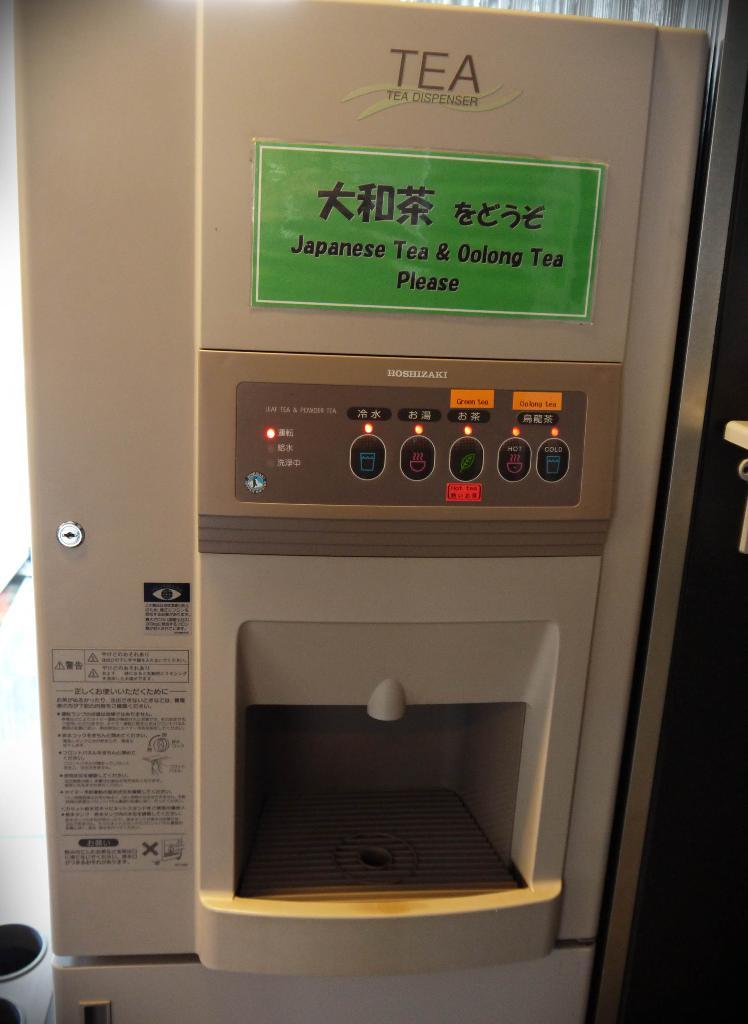<image>
Share a concise interpretation of the image provided. tea machine that says Japenese Tea and Oolong Tea Please. 